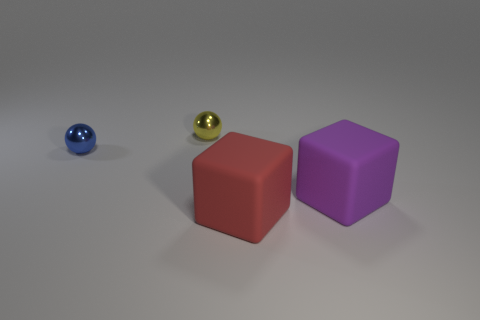There is a metal thing that is the same size as the blue ball; what is its color? The object you're referring to appears to be a sphere with a reflective surface, similar in size to the blue ball on the left. It exhibits a color that could be described as a shiny gold or brass, and its polished metal surface reflects the surrounding environment, giving it a sheen that enhances its golden hue. 